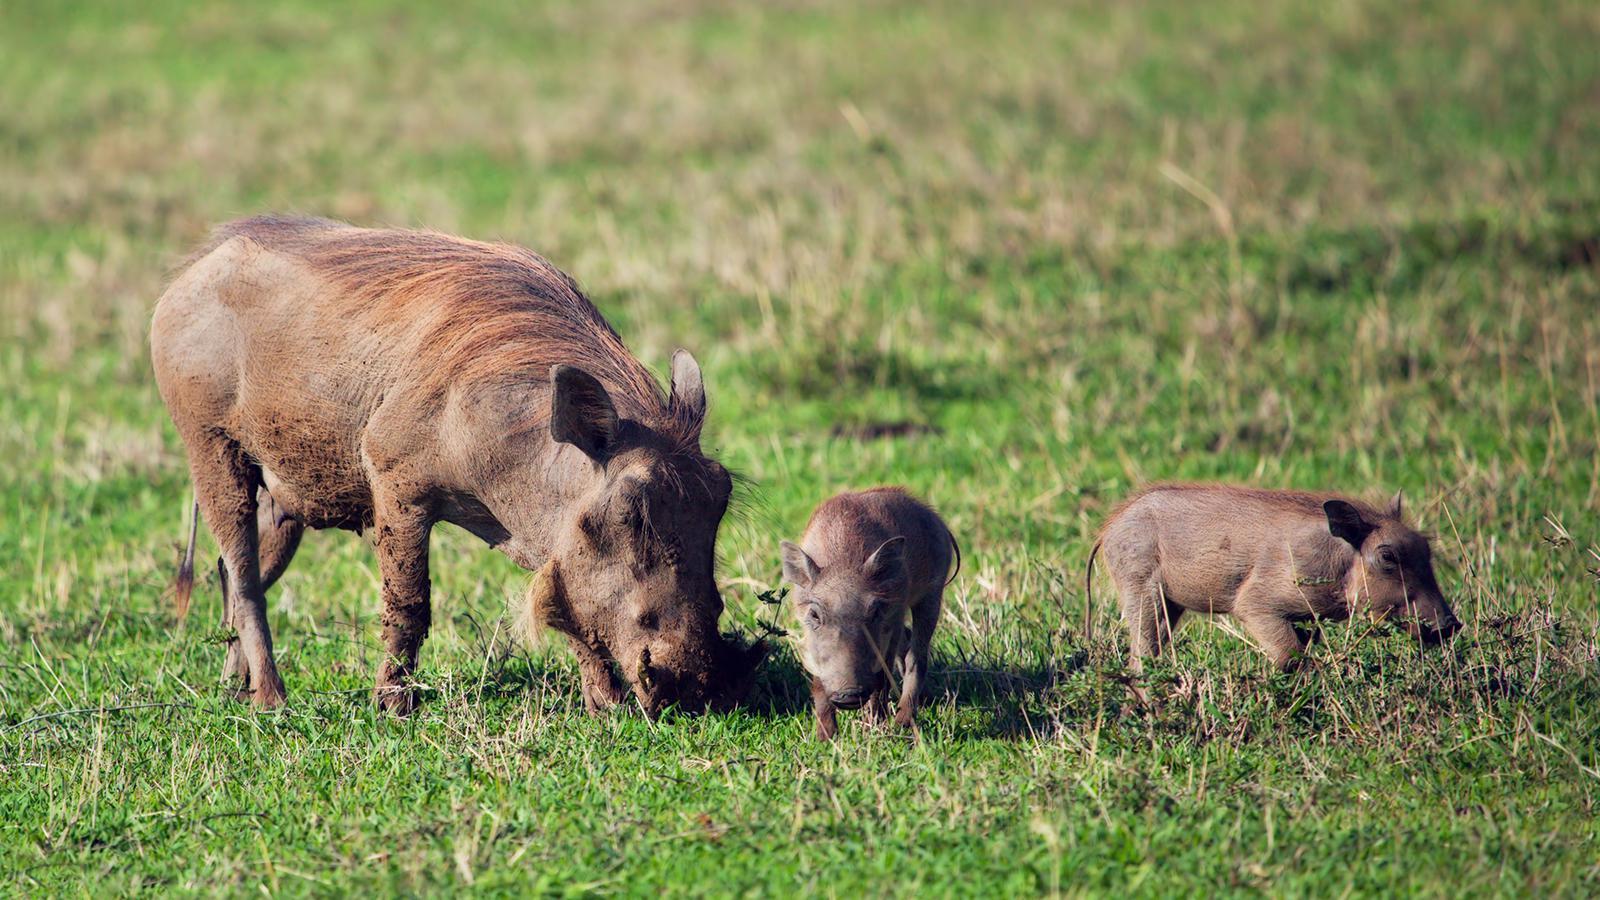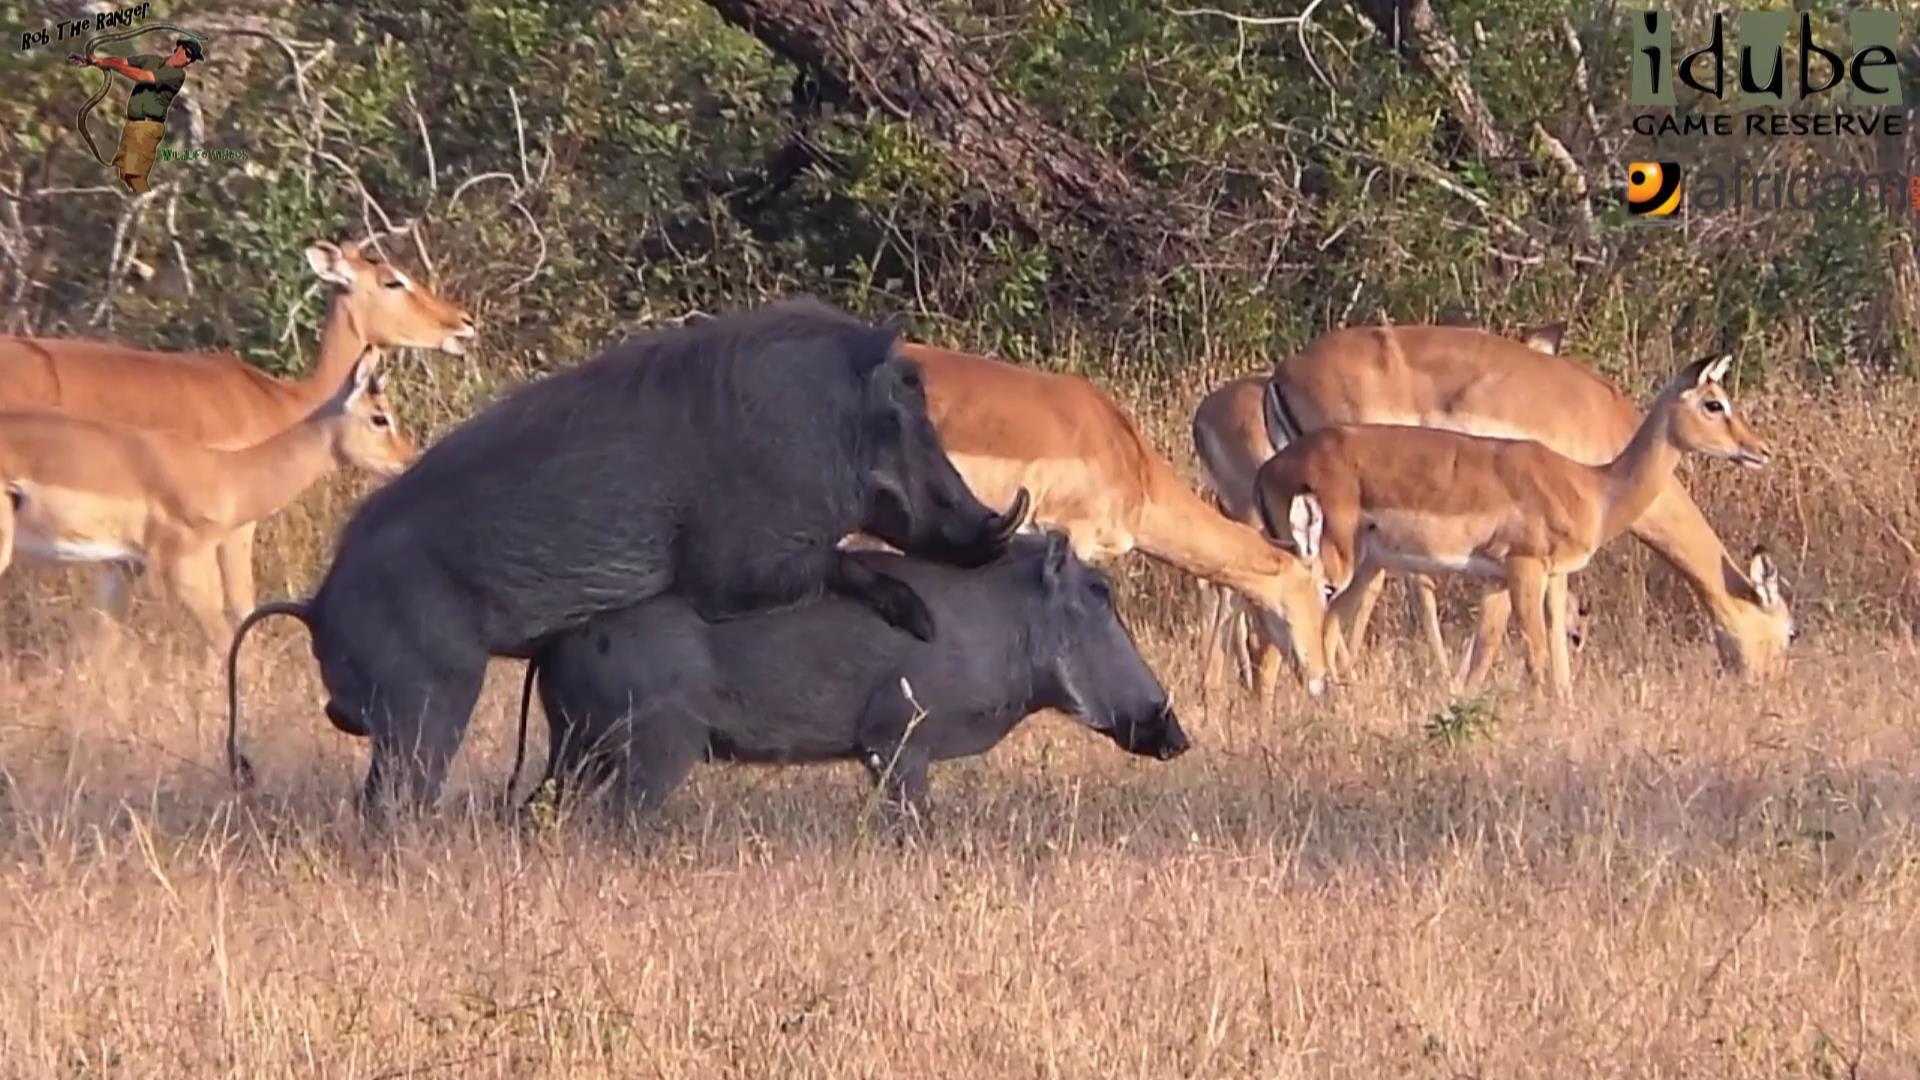The first image is the image on the left, the second image is the image on the right. Given the left and right images, does the statement "there is only one adult animal in the image on the left" hold true? Answer yes or no. Yes. The first image is the image on the left, the second image is the image on the right. Analyze the images presented: Is the assertion "There is at least one hog facing left." valid? Answer yes or no. No. 